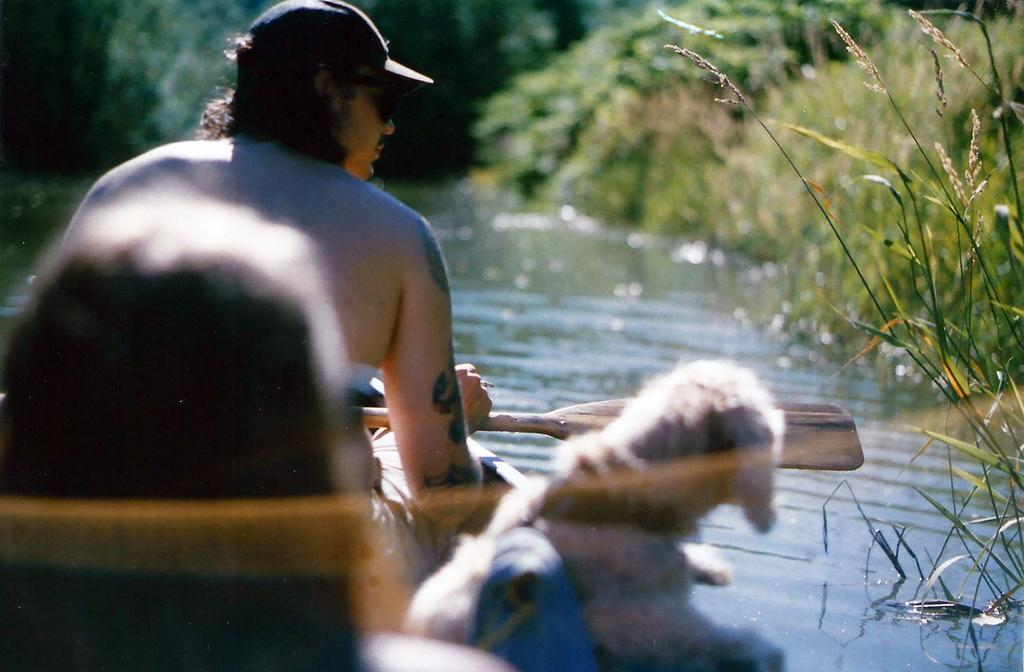What is the person in the image doing? There is a person in a boat in the image. Where is the boat located? The boat is sailing on a river. What can be seen in the background of the image? There are plants and trees in the background of the image. What type of noise can be heard coming from the airplane in the image? There is no airplane present in the image, so it is not possible to determine what, if any, noise might be heard. 